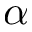<formula> <loc_0><loc_0><loc_500><loc_500>\alpha</formula> 